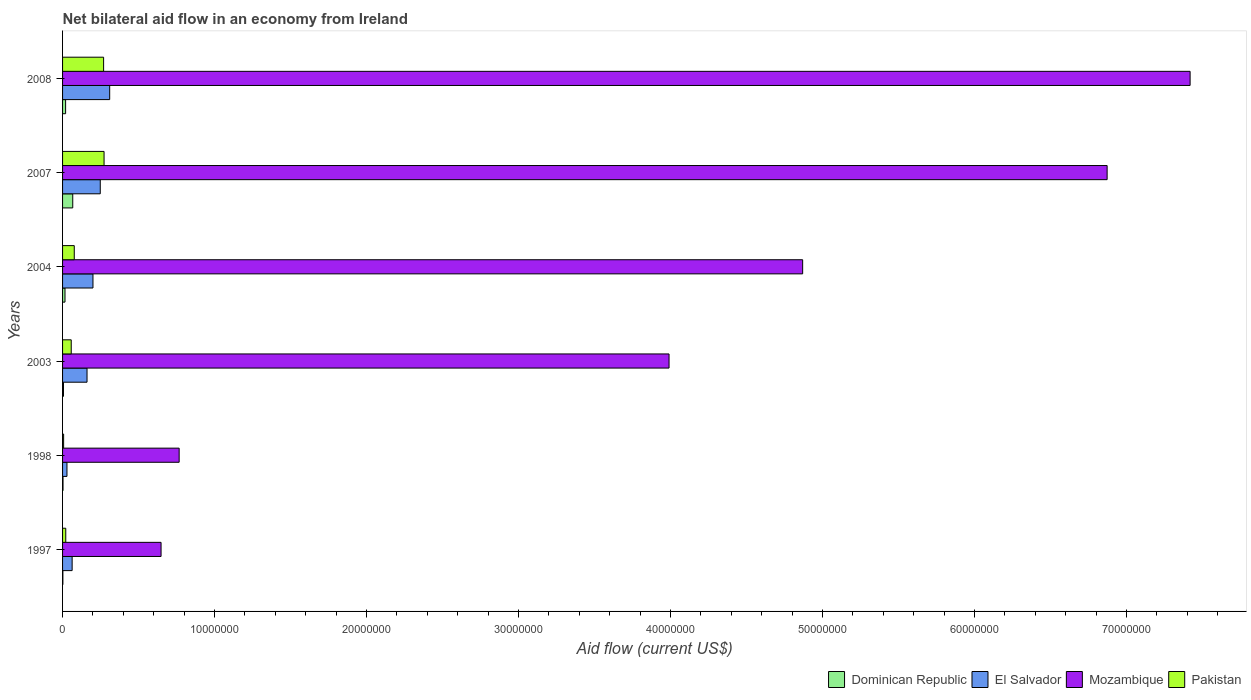How many different coloured bars are there?
Offer a terse response. 4. How many groups of bars are there?
Your answer should be very brief. 6. How many bars are there on the 3rd tick from the top?
Your answer should be very brief. 4. How many bars are there on the 2nd tick from the bottom?
Ensure brevity in your answer.  4. In how many cases, is the number of bars for a given year not equal to the number of legend labels?
Keep it short and to the point. 0. What is the net bilateral aid flow in El Salvador in 1997?
Give a very brief answer. 6.30e+05. Across all years, what is the maximum net bilateral aid flow in Dominican Republic?
Provide a succinct answer. 6.70e+05. Across all years, what is the minimum net bilateral aid flow in Pakistan?
Your response must be concise. 7.00e+04. What is the total net bilateral aid flow in Pakistan in the graph?
Keep it short and to the point. 7.05e+06. What is the difference between the net bilateral aid flow in Dominican Republic in 2007 and that in 2008?
Your response must be concise. 4.70e+05. What is the difference between the net bilateral aid flow in Dominican Republic in 2004 and the net bilateral aid flow in Mozambique in 1997?
Provide a short and direct response. -6.32e+06. What is the average net bilateral aid flow in Dominican Republic per year?
Give a very brief answer. 1.90e+05. In the year 1997, what is the difference between the net bilateral aid flow in Dominican Republic and net bilateral aid flow in Mozambique?
Your answer should be very brief. -6.46e+06. What is the ratio of the net bilateral aid flow in Dominican Republic in 1998 to that in 2007?
Make the answer very short. 0.04. Is the net bilateral aid flow in Pakistan in 1997 less than that in 2008?
Your answer should be very brief. Yes. What is the difference between the highest and the second highest net bilateral aid flow in Dominican Republic?
Give a very brief answer. 4.70e+05. What is the difference between the highest and the lowest net bilateral aid flow in Dominican Republic?
Provide a short and direct response. 6.50e+05. Is the sum of the net bilateral aid flow in Dominican Republic in 1997 and 2004 greater than the maximum net bilateral aid flow in Mozambique across all years?
Offer a terse response. No. What does the 3rd bar from the top in 2003 represents?
Give a very brief answer. El Salvador. What does the 3rd bar from the bottom in 2003 represents?
Provide a succinct answer. Mozambique. How many years are there in the graph?
Provide a short and direct response. 6. What is the difference between two consecutive major ticks on the X-axis?
Provide a succinct answer. 1.00e+07. Are the values on the major ticks of X-axis written in scientific E-notation?
Ensure brevity in your answer.  No. Does the graph contain any zero values?
Provide a succinct answer. No. Does the graph contain grids?
Provide a succinct answer. No. Where does the legend appear in the graph?
Offer a terse response. Bottom right. What is the title of the graph?
Keep it short and to the point. Net bilateral aid flow in an economy from Ireland. Does "Serbia" appear as one of the legend labels in the graph?
Ensure brevity in your answer.  No. What is the label or title of the Y-axis?
Your response must be concise. Years. What is the Aid flow (current US$) in El Salvador in 1997?
Your answer should be compact. 6.30e+05. What is the Aid flow (current US$) in Mozambique in 1997?
Provide a short and direct response. 6.48e+06. What is the Aid flow (current US$) in Pakistan in 1997?
Provide a short and direct response. 2.10e+05. What is the Aid flow (current US$) in Dominican Republic in 1998?
Make the answer very short. 3.00e+04. What is the Aid flow (current US$) in Mozambique in 1998?
Your answer should be very brief. 7.67e+06. What is the Aid flow (current US$) of Dominican Republic in 2003?
Ensure brevity in your answer.  6.00e+04. What is the Aid flow (current US$) in El Salvador in 2003?
Offer a very short reply. 1.61e+06. What is the Aid flow (current US$) in Mozambique in 2003?
Provide a succinct answer. 3.99e+07. What is the Aid flow (current US$) in Pakistan in 2003?
Ensure brevity in your answer.  5.70e+05. What is the Aid flow (current US$) of Dominican Republic in 2004?
Provide a succinct answer. 1.60e+05. What is the Aid flow (current US$) of Mozambique in 2004?
Your response must be concise. 4.87e+07. What is the Aid flow (current US$) in Pakistan in 2004?
Keep it short and to the point. 7.70e+05. What is the Aid flow (current US$) in Dominican Republic in 2007?
Ensure brevity in your answer.  6.70e+05. What is the Aid flow (current US$) of El Salvador in 2007?
Keep it short and to the point. 2.48e+06. What is the Aid flow (current US$) in Mozambique in 2007?
Keep it short and to the point. 6.87e+07. What is the Aid flow (current US$) in Pakistan in 2007?
Make the answer very short. 2.73e+06. What is the Aid flow (current US$) of El Salvador in 2008?
Your answer should be compact. 3.10e+06. What is the Aid flow (current US$) of Mozambique in 2008?
Ensure brevity in your answer.  7.42e+07. What is the Aid flow (current US$) in Pakistan in 2008?
Provide a short and direct response. 2.70e+06. Across all years, what is the maximum Aid flow (current US$) in Dominican Republic?
Make the answer very short. 6.70e+05. Across all years, what is the maximum Aid flow (current US$) in El Salvador?
Ensure brevity in your answer.  3.10e+06. Across all years, what is the maximum Aid flow (current US$) of Mozambique?
Provide a succinct answer. 7.42e+07. Across all years, what is the maximum Aid flow (current US$) of Pakistan?
Ensure brevity in your answer.  2.73e+06. Across all years, what is the minimum Aid flow (current US$) in Dominican Republic?
Keep it short and to the point. 2.00e+04. Across all years, what is the minimum Aid flow (current US$) of El Salvador?
Provide a succinct answer. 2.90e+05. Across all years, what is the minimum Aid flow (current US$) in Mozambique?
Your response must be concise. 6.48e+06. What is the total Aid flow (current US$) in Dominican Republic in the graph?
Provide a succinct answer. 1.14e+06. What is the total Aid flow (current US$) in El Salvador in the graph?
Keep it short and to the point. 1.01e+07. What is the total Aid flow (current US$) in Mozambique in the graph?
Your response must be concise. 2.46e+08. What is the total Aid flow (current US$) of Pakistan in the graph?
Offer a terse response. 7.05e+06. What is the difference between the Aid flow (current US$) of Dominican Republic in 1997 and that in 1998?
Your answer should be very brief. -10000. What is the difference between the Aid flow (current US$) in Mozambique in 1997 and that in 1998?
Make the answer very short. -1.19e+06. What is the difference between the Aid flow (current US$) of Pakistan in 1997 and that in 1998?
Your response must be concise. 1.40e+05. What is the difference between the Aid flow (current US$) in El Salvador in 1997 and that in 2003?
Your response must be concise. -9.80e+05. What is the difference between the Aid flow (current US$) of Mozambique in 1997 and that in 2003?
Ensure brevity in your answer.  -3.34e+07. What is the difference between the Aid flow (current US$) of Pakistan in 1997 and that in 2003?
Provide a succinct answer. -3.60e+05. What is the difference between the Aid flow (current US$) of El Salvador in 1997 and that in 2004?
Offer a very short reply. -1.37e+06. What is the difference between the Aid flow (current US$) of Mozambique in 1997 and that in 2004?
Your response must be concise. -4.22e+07. What is the difference between the Aid flow (current US$) in Pakistan in 1997 and that in 2004?
Give a very brief answer. -5.60e+05. What is the difference between the Aid flow (current US$) in Dominican Republic in 1997 and that in 2007?
Your response must be concise. -6.50e+05. What is the difference between the Aid flow (current US$) in El Salvador in 1997 and that in 2007?
Offer a terse response. -1.85e+06. What is the difference between the Aid flow (current US$) of Mozambique in 1997 and that in 2007?
Provide a short and direct response. -6.22e+07. What is the difference between the Aid flow (current US$) of Pakistan in 1997 and that in 2007?
Provide a succinct answer. -2.52e+06. What is the difference between the Aid flow (current US$) of Dominican Republic in 1997 and that in 2008?
Ensure brevity in your answer.  -1.80e+05. What is the difference between the Aid flow (current US$) in El Salvador in 1997 and that in 2008?
Provide a succinct answer. -2.47e+06. What is the difference between the Aid flow (current US$) in Mozambique in 1997 and that in 2008?
Offer a terse response. -6.77e+07. What is the difference between the Aid flow (current US$) of Pakistan in 1997 and that in 2008?
Provide a succinct answer. -2.49e+06. What is the difference between the Aid flow (current US$) in El Salvador in 1998 and that in 2003?
Offer a terse response. -1.32e+06. What is the difference between the Aid flow (current US$) in Mozambique in 1998 and that in 2003?
Provide a short and direct response. -3.22e+07. What is the difference between the Aid flow (current US$) of Pakistan in 1998 and that in 2003?
Ensure brevity in your answer.  -5.00e+05. What is the difference between the Aid flow (current US$) in El Salvador in 1998 and that in 2004?
Make the answer very short. -1.71e+06. What is the difference between the Aid flow (current US$) of Mozambique in 1998 and that in 2004?
Offer a very short reply. -4.10e+07. What is the difference between the Aid flow (current US$) in Pakistan in 1998 and that in 2004?
Your response must be concise. -7.00e+05. What is the difference between the Aid flow (current US$) in Dominican Republic in 1998 and that in 2007?
Your answer should be very brief. -6.40e+05. What is the difference between the Aid flow (current US$) of El Salvador in 1998 and that in 2007?
Offer a terse response. -2.19e+06. What is the difference between the Aid flow (current US$) of Mozambique in 1998 and that in 2007?
Your answer should be very brief. -6.10e+07. What is the difference between the Aid flow (current US$) in Pakistan in 1998 and that in 2007?
Ensure brevity in your answer.  -2.66e+06. What is the difference between the Aid flow (current US$) in El Salvador in 1998 and that in 2008?
Your answer should be compact. -2.81e+06. What is the difference between the Aid flow (current US$) in Mozambique in 1998 and that in 2008?
Make the answer very short. -6.65e+07. What is the difference between the Aid flow (current US$) in Pakistan in 1998 and that in 2008?
Give a very brief answer. -2.63e+06. What is the difference between the Aid flow (current US$) in El Salvador in 2003 and that in 2004?
Your answer should be very brief. -3.90e+05. What is the difference between the Aid flow (current US$) of Mozambique in 2003 and that in 2004?
Your answer should be very brief. -8.79e+06. What is the difference between the Aid flow (current US$) of Dominican Republic in 2003 and that in 2007?
Offer a terse response. -6.10e+05. What is the difference between the Aid flow (current US$) of El Salvador in 2003 and that in 2007?
Your response must be concise. -8.70e+05. What is the difference between the Aid flow (current US$) in Mozambique in 2003 and that in 2007?
Keep it short and to the point. -2.88e+07. What is the difference between the Aid flow (current US$) of Pakistan in 2003 and that in 2007?
Offer a very short reply. -2.16e+06. What is the difference between the Aid flow (current US$) in Dominican Republic in 2003 and that in 2008?
Your answer should be compact. -1.40e+05. What is the difference between the Aid flow (current US$) of El Salvador in 2003 and that in 2008?
Your answer should be very brief. -1.49e+06. What is the difference between the Aid flow (current US$) of Mozambique in 2003 and that in 2008?
Provide a short and direct response. -3.43e+07. What is the difference between the Aid flow (current US$) in Pakistan in 2003 and that in 2008?
Offer a very short reply. -2.13e+06. What is the difference between the Aid flow (current US$) in Dominican Republic in 2004 and that in 2007?
Offer a very short reply. -5.10e+05. What is the difference between the Aid flow (current US$) of El Salvador in 2004 and that in 2007?
Give a very brief answer. -4.80e+05. What is the difference between the Aid flow (current US$) in Mozambique in 2004 and that in 2007?
Make the answer very short. -2.00e+07. What is the difference between the Aid flow (current US$) of Pakistan in 2004 and that in 2007?
Your response must be concise. -1.96e+06. What is the difference between the Aid flow (current US$) in Dominican Republic in 2004 and that in 2008?
Give a very brief answer. -4.00e+04. What is the difference between the Aid flow (current US$) of El Salvador in 2004 and that in 2008?
Offer a very short reply. -1.10e+06. What is the difference between the Aid flow (current US$) of Mozambique in 2004 and that in 2008?
Offer a very short reply. -2.55e+07. What is the difference between the Aid flow (current US$) in Pakistan in 2004 and that in 2008?
Provide a succinct answer. -1.93e+06. What is the difference between the Aid flow (current US$) in Dominican Republic in 2007 and that in 2008?
Keep it short and to the point. 4.70e+05. What is the difference between the Aid flow (current US$) in El Salvador in 2007 and that in 2008?
Provide a short and direct response. -6.20e+05. What is the difference between the Aid flow (current US$) of Mozambique in 2007 and that in 2008?
Offer a terse response. -5.46e+06. What is the difference between the Aid flow (current US$) in Dominican Republic in 1997 and the Aid flow (current US$) in El Salvador in 1998?
Your answer should be compact. -2.70e+05. What is the difference between the Aid flow (current US$) of Dominican Republic in 1997 and the Aid flow (current US$) of Mozambique in 1998?
Your response must be concise. -7.65e+06. What is the difference between the Aid flow (current US$) in El Salvador in 1997 and the Aid flow (current US$) in Mozambique in 1998?
Your answer should be compact. -7.04e+06. What is the difference between the Aid flow (current US$) in El Salvador in 1997 and the Aid flow (current US$) in Pakistan in 1998?
Your answer should be compact. 5.60e+05. What is the difference between the Aid flow (current US$) in Mozambique in 1997 and the Aid flow (current US$) in Pakistan in 1998?
Offer a terse response. 6.41e+06. What is the difference between the Aid flow (current US$) of Dominican Republic in 1997 and the Aid flow (current US$) of El Salvador in 2003?
Keep it short and to the point. -1.59e+06. What is the difference between the Aid flow (current US$) in Dominican Republic in 1997 and the Aid flow (current US$) in Mozambique in 2003?
Give a very brief answer. -3.99e+07. What is the difference between the Aid flow (current US$) in Dominican Republic in 1997 and the Aid flow (current US$) in Pakistan in 2003?
Provide a short and direct response. -5.50e+05. What is the difference between the Aid flow (current US$) in El Salvador in 1997 and the Aid flow (current US$) in Mozambique in 2003?
Provide a short and direct response. -3.93e+07. What is the difference between the Aid flow (current US$) in Mozambique in 1997 and the Aid flow (current US$) in Pakistan in 2003?
Ensure brevity in your answer.  5.91e+06. What is the difference between the Aid flow (current US$) in Dominican Republic in 1997 and the Aid flow (current US$) in El Salvador in 2004?
Keep it short and to the point. -1.98e+06. What is the difference between the Aid flow (current US$) in Dominican Republic in 1997 and the Aid flow (current US$) in Mozambique in 2004?
Your answer should be very brief. -4.87e+07. What is the difference between the Aid flow (current US$) of Dominican Republic in 1997 and the Aid flow (current US$) of Pakistan in 2004?
Ensure brevity in your answer.  -7.50e+05. What is the difference between the Aid flow (current US$) of El Salvador in 1997 and the Aid flow (current US$) of Mozambique in 2004?
Your answer should be compact. -4.81e+07. What is the difference between the Aid flow (current US$) of Mozambique in 1997 and the Aid flow (current US$) of Pakistan in 2004?
Provide a succinct answer. 5.71e+06. What is the difference between the Aid flow (current US$) in Dominican Republic in 1997 and the Aid flow (current US$) in El Salvador in 2007?
Offer a very short reply. -2.46e+06. What is the difference between the Aid flow (current US$) in Dominican Republic in 1997 and the Aid flow (current US$) in Mozambique in 2007?
Offer a very short reply. -6.87e+07. What is the difference between the Aid flow (current US$) in Dominican Republic in 1997 and the Aid flow (current US$) in Pakistan in 2007?
Offer a very short reply. -2.71e+06. What is the difference between the Aid flow (current US$) in El Salvador in 1997 and the Aid flow (current US$) in Mozambique in 2007?
Provide a succinct answer. -6.81e+07. What is the difference between the Aid flow (current US$) of El Salvador in 1997 and the Aid flow (current US$) of Pakistan in 2007?
Your answer should be very brief. -2.10e+06. What is the difference between the Aid flow (current US$) in Mozambique in 1997 and the Aid flow (current US$) in Pakistan in 2007?
Offer a very short reply. 3.75e+06. What is the difference between the Aid flow (current US$) of Dominican Republic in 1997 and the Aid flow (current US$) of El Salvador in 2008?
Your answer should be very brief. -3.08e+06. What is the difference between the Aid flow (current US$) in Dominican Republic in 1997 and the Aid flow (current US$) in Mozambique in 2008?
Offer a very short reply. -7.42e+07. What is the difference between the Aid flow (current US$) of Dominican Republic in 1997 and the Aid flow (current US$) of Pakistan in 2008?
Your answer should be compact. -2.68e+06. What is the difference between the Aid flow (current US$) in El Salvador in 1997 and the Aid flow (current US$) in Mozambique in 2008?
Ensure brevity in your answer.  -7.36e+07. What is the difference between the Aid flow (current US$) in El Salvador in 1997 and the Aid flow (current US$) in Pakistan in 2008?
Give a very brief answer. -2.07e+06. What is the difference between the Aid flow (current US$) of Mozambique in 1997 and the Aid flow (current US$) of Pakistan in 2008?
Your response must be concise. 3.78e+06. What is the difference between the Aid flow (current US$) of Dominican Republic in 1998 and the Aid flow (current US$) of El Salvador in 2003?
Your response must be concise. -1.58e+06. What is the difference between the Aid flow (current US$) in Dominican Republic in 1998 and the Aid flow (current US$) in Mozambique in 2003?
Ensure brevity in your answer.  -3.99e+07. What is the difference between the Aid flow (current US$) in Dominican Republic in 1998 and the Aid flow (current US$) in Pakistan in 2003?
Ensure brevity in your answer.  -5.40e+05. What is the difference between the Aid flow (current US$) of El Salvador in 1998 and the Aid flow (current US$) of Mozambique in 2003?
Provide a succinct answer. -3.96e+07. What is the difference between the Aid flow (current US$) of El Salvador in 1998 and the Aid flow (current US$) of Pakistan in 2003?
Make the answer very short. -2.80e+05. What is the difference between the Aid flow (current US$) of Mozambique in 1998 and the Aid flow (current US$) of Pakistan in 2003?
Provide a short and direct response. 7.10e+06. What is the difference between the Aid flow (current US$) of Dominican Republic in 1998 and the Aid flow (current US$) of El Salvador in 2004?
Keep it short and to the point. -1.97e+06. What is the difference between the Aid flow (current US$) of Dominican Republic in 1998 and the Aid flow (current US$) of Mozambique in 2004?
Offer a terse response. -4.87e+07. What is the difference between the Aid flow (current US$) in Dominican Republic in 1998 and the Aid flow (current US$) in Pakistan in 2004?
Make the answer very short. -7.40e+05. What is the difference between the Aid flow (current US$) in El Salvador in 1998 and the Aid flow (current US$) in Mozambique in 2004?
Your answer should be very brief. -4.84e+07. What is the difference between the Aid flow (current US$) of El Salvador in 1998 and the Aid flow (current US$) of Pakistan in 2004?
Provide a short and direct response. -4.80e+05. What is the difference between the Aid flow (current US$) in Mozambique in 1998 and the Aid flow (current US$) in Pakistan in 2004?
Provide a succinct answer. 6.90e+06. What is the difference between the Aid flow (current US$) in Dominican Republic in 1998 and the Aid flow (current US$) in El Salvador in 2007?
Provide a short and direct response. -2.45e+06. What is the difference between the Aid flow (current US$) in Dominican Republic in 1998 and the Aid flow (current US$) in Mozambique in 2007?
Ensure brevity in your answer.  -6.87e+07. What is the difference between the Aid flow (current US$) in Dominican Republic in 1998 and the Aid flow (current US$) in Pakistan in 2007?
Offer a terse response. -2.70e+06. What is the difference between the Aid flow (current US$) in El Salvador in 1998 and the Aid flow (current US$) in Mozambique in 2007?
Make the answer very short. -6.84e+07. What is the difference between the Aid flow (current US$) in El Salvador in 1998 and the Aid flow (current US$) in Pakistan in 2007?
Ensure brevity in your answer.  -2.44e+06. What is the difference between the Aid flow (current US$) of Mozambique in 1998 and the Aid flow (current US$) of Pakistan in 2007?
Your response must be concise. 4.94e+06. What is the difference between the Aid flow (current US$) of Dominican Republic in 1998 and the Aid flow (current US$) of El Salvador in 2008?
Offer a very short reply. -3.07e+06. What is the difference between the Aid flow (current US$) in Dominican Republic in 1998 and the Aid flow (current US$) in Mozambique in 2008?
Make the answer very short. -7.42e+07. What is the difference between the Aid flow (current US$) in Dominican Republic in 1998 and the Aid flow (current US$) in Pakistan in 2008?
Make the answer very short. -2.67e+06. What is the difference between the Aid flow (current US$) of El Salvador in 1998 and the Aid flow (current US$) of Mozambique in 2008?
Give a very brief answer. -7.39e+07. What is the difference between the Aid flow (current US$) in El Salvador in 1998 and the Aid flow (current US$) in Pakistan in 2008?
Your answer should be very brief. -2.41e+06. What is the difference between the Aid flow (current US$) of Mozambique in 1998 and the Aid flow (current US$) of Pakistan in 2008?
Give a very brief answer. 4.97e+06. What is the difference between the Aid flow (current US$) in Dominican Republic in 2003 and the Aid flow (current US$) in El Salvador in 2004?
Your response must be concise. -1.94e+06. What is the difference between the Aid flow (current US$) in Dominican Republic in 2003 and the Aid flow (current US$) in Mozambique in 2004?
Give a very brief answer. -4.86e+07. What is the difference between the Aid flow (current US$) in Dominican Republic in 2003 and the Aid flow (current US$) in Pakistan in 2004?
Provide a succinct answer. -7.10e+05. What is the difference between the Aid flow (current US$) in El Salvador in 2003 and the Aid flow (current US$) in Mozambique in 2004?
Give a very brief answer. -4.71e+07. What is the difference between the Aid flow (current US$) of El Salvador in 2003 and the Aid flow (current US$) of Pakistan in 2004?
Give a very brief answer. 8.40e+05. What is the difference between the Aid flow (current US$) of Mozambique in 2003 and the Aid flow (current US$) of Pakistan in 2004?
Your response must be concise. 3.91e+07. What is the difference between the Aid flow (current US$) of Dominican Republic in 2003 and the Aid flow (current US$) of El Salvador in 2007?
Ensure brevity in your answer.  -2.42e+06. What is the difference between the Aid flow (current US$) of Dominican Republic in 2003 and the Aid flow (current US$) of Mozambique in 2007?
Keep it short and to the point. -6.87e+07. What is the difference between the Aid flow (current US$) in Dominican Republic in 2003 and the Aid flow (current US$) in Pakistan in 2007?
Offer a terse response. -2.67e+06. What is the difference between the Aid flow (current US$) of El Salvador in 2003 and the Aid flow (current US$) of Mozambique in 2007?
Keep it short and to the point. -6.71e+07. What is the difference between the Aid flow (current US$) in El Salvador in 2003 and the Aid flow (current US$) in Pakistan in 2007?
Provide a short and direct response. -1.12e+06. What is the difference between the Aid flow (current US$) of Mozambique in 2003 and the Aid flow (current US$) of Pakistan in 2007?
Give a very brief answer. 3.72e+07. What is the difference between the Aid flow (current US$) of Dominican Republic in 2003 and the Aid flow (current US$) of El Salvador in 2008?
Offer a very short reply. -3.04e+06. What is the difference between the Aid flow (current US$) of Dominican Republic in 2003 and the Aid flow (current US$) of Mozambique in 2008?
Provide a short and direct response. -7.41e+07. What is the difference between the Aid flow (current US$) of Dominican Republic in 2003 and the Aid flow (current US$) of Pakistan in 2008?
Keep it short and to the point. -2.64e+06. What is the difference between the Aid flow (current US$) in El Salvador in 2003 and the Aid flow (current US$) in Mozambique in 2008?
Provide a succinct answer. -7.26e+07. What is the difference between the Aid flow (current US$) of El Salvador in 2003 and the Aid flow (current US$) of Pakistan in 2008?
Give a very brief answer. -1.09e+06. What is the difference between the Aid flow (current US$) of Mozambique in 2003 and the Aid flow (current US$) of Pakistan in 2008?
Make the answer very short. 3.72e+07. What is the difference between the Aid flow (current US$) in Dominican Republic in 2004 and the Aid flow (current US$) in El Salvador in 2007?
Offer a terse response. -2.32e+06. What is the difference between the Aid flow (current US$) in Dominican Republic in 2004 and the Aid flow (current US$) in Mozambique in 2007?
Your answer should be compact. -6.86e+07. What is the difference between the Aid flow (current US$) in Dominican Republic in 2004 and the Aid flow (current US$) in Pakistan in 2007?
Offer a terse response. -2.57e+06. What is the difference between the Aid flow (current US$) in El Salvador in 2004 and the Aid flow (current US$) in Mozambique in 2007?
Your answer should be very brief. -6.67e+07. What is the difference between the Aid flow (current US$) in El Salvador in 2004 and the Aid flow (current US$) in Pakistan in 2007?
Offer a very short reply. -7.30e+05. What is the difference between the Aid flow (current US$) of Mozambique in 2004 and the Aid flow (current US$) of Pakistan in 2007?
Your answer should be very brief. 4.60e+07. What is the difference between the Aid flow (current US$) in Dominican Republic in 2004 and the Aid flow (current US$) in El Salvador in 2008?
Keep it short and to the point. -2.94e+06. What is the difference between the Aid flow (current US$) in Dominican Republic in 2004 and the Aid flow (current US$) in Mozambique in 2008?
Provide a short and direct response. -7.40e+07. What is the difference between the Aid flow (current US$) in Dominican Republic in 2004 and the Aid flow (current US$) in Pakistan in 2008?
Provide a short and direct response. -2.54e+06. What is the difference between the Aid flow (current US$) in El Salvador in 2004 and the Aid flow (current US$) in Mozambique in 2008?
Offer a terse response. -7.22e+07. What is the difference between the Aid flow (current US$) of El Salvador in 2004 and the Aid flow (current US$) of Pakistan in 2008?
Provide a short and direct response. -7.00e+05. What is the difference between the Aid flow (current US$) in Mozambique in 2004 and the Aid flow (current US$) in Pakistan in 2008?
Your answer should be very brief. 4.60e+07. What is the difference between the Aid flow (current US$) in Dominican Republic in 2007 and the Aid flow (current US$) in El Salvador in 2008?
Your answer should be compact. -2.43e+06. What is the difference between the Aid flow (current US$) of Dominican Republic in 2007 and the Aid flow (current US$) of Mozambique in 2008?
Provide a succinct answer. -7.35e+07. What is the difference between the Aid flow (current US$) in Dominican Republic in 2007 and the Aid flow (current US$) in Pakistan in 2008?
Provide a succinct answer. -2.03e+06. What is the difference between the Aid flow (current US$) in El Salvador in 2007 and the Aid flow (current US$) in Mozambique in 2008?
Provide a succinct answer. -7.17e+07. What is the difference between the Aid flow (current US$) in Mozambique in 2007 and the Aid flow (current US$) in Pakistan in 2008?
Make the answer very short. 6.60e+07. What is the average Aid flow (current US$) of Dominican Republic per year?
Your answer should be very brief. 1.90e+05. What is the average Aid flow (current US$) of El Salvador per year?
Make the answer very short. 1.68e+06. What is the average Aid flow (current US$) of Mozambique per year?
Your answer should be very brief. 4.09e+07. What is the average Aid flow (current US$) of Pakistan per year?
Provide a succinct answer. 1.18e+06. In the year 1997, what is the difference between the Aid flow (current US$) in Dominican Republic and Aid flow (current US$) in El Salvador?
Ensure brevity in your answer.  -6.10e+05. In the year 1997, what is the difference between the Aid flow (current US$) of Dominican Republic and Aid flow (current US$) of Mozambique?
Offer a very short reply. -6.46e+06. In the year 1997, what is the difference between the Aid flow (current US$) of El Salvador and Aid flow (current US$) of Mozambique?
Offer a terse response. -5.85e+06. In the year 1997, what is the difference between the Aid flow (current US$) of Mozambique and Aid flow (current US$) of Pakistan?
Your answer should be very brief. 6.27e+06. In the year 1998, what is the difference between the Aid flow (current US$) of Dominican Republic and Aid flow (current US$) of Mozambique?
Keep it short and to the point. -7.64e+06. In the year 1998, what is the difference between the Aid flow (current US$) of El Salvador and Aid flow (current US$) of Mozambique?
Your answer should be compact. -7.38e+06. In the year 1998, what is the difference between the Aid flow (current US$) in El Salvador and Aid flow (current US$) in Pakistan?
Keep it short and to the point. 2.20e+05. In the year 1998, what is the difference between the Aid flow (current US$) of Mozambique and Aid flow (current US$) of Pakistan?
Offer a terse response. 7.60e+06. In the year 2003, what is the difference between the Aid flow (current US$) of Dominican Republic and Aid flow (current US$) of El Salvador?
Keep it short and to the point. -1.55e+06. In the year 2003, what is the difference between the Aid flow (current US$) of Dominican Republic and Aid flow (current US$) of Mozambique?
Give a very brief answer. -3.98e+07. In the year 2003, what is the difference between the Aid flow (current US$) of Dominican Republic and Aid flow (current US$) of Pakistan?
Make the answer very short. -5.10e+05. In the year 2003, what is the difference between the Aid flow (current US$) of El Salvador and Aid flow (current US$) of Mozambique?
Offer a very short reply. -3.83e+07. In the year 2003, what is the difference between the Aid flow (current US$) of El Salvador and Aid flow (current US$) of Pakistan?
Make the answer very short. 1.04e+06. In the year 2003, what is the difference between the Aid flow (current US$) of Mozambique and Aid flow (current US$) of Pakistan?
Your answer should be very brief. 3.93e+07. In the year 2004, what is the difference between the Aid flow (current US$) of Dominican Republic and Aid flow (current US$) of El Salvador?
Offer a very short reply. -1.84e+06. In the year 2004, what is the difference between the Aid flow (current US$) in Dominican Republic and Aid flow (current US$) in Mozambique?
Provide a short and direct response. -4.85e+07. In the year 2004, what is the difference between the Aid flow (current US$) in Dominican Republic and Aid flow (current US$) in Pakistan?
Your answer should be very brief. -6.10e+05. In the year 2004, what is the difference between the Aid flow (current US$) in El Salvador and Aid flow (current US$) in Mozambique?
Your answer should be very brief. -4.67e+07. In the year 2004, what is the difference between the Aid flow (current US$) in El Salvador and Aid flow (current US$) in Pakistan?
Ensure brevity in your answer.  1.23e+06. In the year 2004, what is the difference between the Aid flow (current US$) of Mozambique and Aid flow (current US$) of Pakistan?
Ensure brevity in your answer.  4.79e+07. In the year 2007, what is the difference between the Aid flow (current US$) in Dominican Republic and Aid flow (current US$) in El Salvador?
Your answer should be compact. -1.81e+06. In the year 2007, what is the difference between the Aid flow (current US$) in Dominican Republic and Aid flow (current US$) in Mozambique?
Provide a short and direct response. -6.80e+07. In the year 2007, what is the difference between the Aid flow (current US$) in Dominican Republic and Aid flow (current US$) in Pakistan?
Give a very brief answer. -2.06e+06. In the year 2007, what is the difference between the Aid flow (current US$) in El Salvador and Aid flow (current US$) in Mozambique?
Your answer should be compact. -6.62e+07. In the year 2007, what is the difference between the Aid flow (current US$) in El Salvador and Aid flow (current US$) in Pakistan?
Your answer should be compact. -2.50e+05. In the year 2007, what is the difference between the Aid flow (current US$) in Mozambique and Aid flow (current US$) in Pakistan?
Your answer should be compact. 6.60e+07. In the year 2008, what is the difference between the Aid flow (current US$) of Dominican Republic and Aid flow (current US$) of El Salvador?
Provide a succinct answer. -2.90e+06. In the year 2008, what is the difference between the Aid flow (current US$) in Dominican Republic and Aid flow (current US$) in Mozambique?
Offer a terse response. -7.40e+07. In the year 2008, what is the difference between the Aid flow (current US$) in Dominican Republic and Aid flow (current US$) in Pakistan?
Provide a short and direct response. -2.50e+06. In the year 2008, what is the difference between the Aid flow (current US$) of El Salvador and Aid flow (current US$) of Mozambique?
Give a very brief answer. -7.11e+07. In the year 2008, what is the difference between the Aid flow (current US$) in El Salvador and Aid flow (current US$) in Pakistan?
Keep it short and to the point. 4.00e+05. In the year 2008, what is the difference between the Aid flow (current US$) of Mozambique and Aid flow (current US$) of Pakistan?
Ensure brevity in your answer.  7.15e+07. What is the ratio of the Aid flow (current US$) in Dominican Republic in 1997 to that in 1998?
Make the answer very short. 0.67. What is the ratio of the Aid flow (current US$) in El Salvador in 1997 to that in 1998?
Give a very brief answer. 2.17. What is the ratio of the Aid flow (current US$) in Mozambique in 1997 to that in 1998?
Offer a terse response. 0.84. What is the ratio of the Aid flow (current US$) of El Salvador in 1997 to that in 2003?
Make the answer very short. 0.39. What is the ratio of the Aid flow (current US$) in Mozambique in 1997 to that in 2003?
Your response must be concise. 0.16. What is the ratio of the Aid flow (current US$) of Pakistan in 1997 to that in 2003?
Provide a short and direct response. 0.37. What is the ratio of the Aid flow (current US$) of Dominican Republic in 1997 to that in 2004?
Offer a terse response. 0.12. What is the ratio of the Aid flow (current US$) of El Salvador in 1997 to that in 2004?
Give a very brief answer. 0.32. What is the ratio of the Aid flow (current US$) in Mozambique in 1997 to that in 2004?
Your answer should be compact. 0.13. What is the ratio of the Aid flow (current US$) in Pakistan in 1997 to that in 2004?
Provide a succinct answer. 0.27. What is the ratio of the Aid flow (current US$) of Dominican Republic in 1997 to that in 2007?
Your answer should be compact. 0.03. What is the ratio of the Aid flow (current US$) in El Salvador in 1997 to that in 2007?
Offer a terse response. 0.25. What is the ratio of the Aid flow (current US$) in Mozambique in 1997 to that in 2007?
Your answer should be very brief. 0.09. What is the ratio of the Aid flow (current US$) in Pakistan in 1997 to that in 2007?
Provide a short and direct response. 0.08. What is the ratio of the Aid flow (current US$) of Dominican Republic in 1997 to that in 2008?
Your answer should be very brief. 0.1. What is the ratio of the Aid flow (current US$) in El Salvador in 1997 to that in 2008?
Offer a terse response. 0.2. What is the ratio of the Aid flow (current US$) of Mozambique in 1997 to that in 2008?
Make the answer very short. 0.09. What is the ratio of the Aid flow (current US$) of Pakistan in 1997 to that in 2008?
Your response must be concise. 0.08. What is the ratio of the Aid flow (current US$) in El Salvador in 1998 to that in 2003?
Your answer should be compact. 0.18. What is the ratio of the Aid flow (current US$) in Mozambique in 1998 to that in 2003?
Offer a very short reply. 0.19. What is the ratio of the Aid flow (current US$) of Pakistan in 1998 to that in 2003?
Your answer should be compact. 0.12. What is the ratio of the Aid flow (current US$) of Dominican Republic in 1998 to that in 2004?
Your answer should be very brief. 0.19. What is the ratio of the Aid flow (current US$) in El Salvador in 1998 to that in 2004?
Make the answer very short. 0.14. What is the ratio of the Aid flow (current US$) of Mozambique in 1998 to that in 2004?
Ensure brevity in your answer.  0.16. What is the ratio of the Aid flow (current US$) in Pakistan in 1998 to that in 2004?
Keep it short and to the point. 0.09. What is the ratio of the Aid flow (current US$) of Dominican Republic in 1998 to that in 2007?
Offer a very short reply. 0.04. What is the ratio of the Aid flow (current US$) of El Salvador in 1998 to that in 2007?
Make the answer very short. 0.12. What is the ratio of the Aid flow (current US$) of Mozambique in 1998 to that in 2007?
Your answer should be very brief. 0.11. What is the ratio of the Aid flow (current US$) of Pakistan in 1998 to that in 2007?
Your answer should be compact. 0.03. What is the ratio of the Aid flow (current US$) in El Salvador in 1998 to that in 2008?
Provide a succinct answer. 0.09. What is the ratio of the Aid flow (current US$) of Mozambique in 1998 to that in 2008?
Your response must be concise. 0.1. What is the ratio of the Aid flow (current US$) of Pakistan in 1998 to that in 2008?
Provide a succinct answer. 0.03. What is the ratio of the Aid flow (current US$) of El Salvador in 2003 to that in 2004?
Provide a succinct answer. 0.81. What is the ratio of the Aid flow (current US$) of Mozambique in 2003 to that in 2004?
Give a very brief answer. 0.82. What is the ratio of the Aid flow (current US$) of Pakistan in 2003 to that in 2004?
Offer a terse response. 0.74. What is the ratio of the Aid flow (current US$) in Dominican Republic in 2003 to that in 2007?
Your response must be concise. 0.09. What is the ratio of the Aid flow (current US$) of El Salvador in 2003 to that in 2007?
Ensure brevity in your answer.  0.65. What is the ratio of the Aid flow (current US$) of Mozambique in 2003 to that in 2007?
Your answer should be compact. 0.58. What is the ratio of the Aid flow (current US$) of Pakistan in 2003 to that in 2007?
Provide a succinct answer. 0.21. What is the ratio of the Aid flow (current US$) of El Salvador in 2003 to that in 2008?
Provide a succinct answer. 0.52. What is the ratio of the Aid flow (current US$) in Mozambique in 2003 to that in 2008?
Offer a terse response. 0.54. What is the ratio of the Aid flow (current US$) of Pakistan in 2003 to that in 2008?
Provide a succinct answer. 0.21. What is the ratio of the Aid flow (current US$) of Dominican Republic in 2004 to that in 2007?
Offer a very short reply. 0.24. What is the ratio of the Aid flow (current US$) in El Salvador in 2004 to that in 2007?
Keep it short and to the point. 0.81. What is the ratio of the Aid flow (current US$) of Mozambique in 2004 to that in 2007?
Give a very brief answer. 0.71. What is the ratio of the Aid flow (current US$) of Pakistan in 2004 to that in 2007?
Your response must be concise. 0.28. What is the ratio of the Aid flow (current US$) of Dominican Republic in 2004 to that in 2008?
Give a very brief answer. 0.8. What is the ratio of the Aid flow (current US$) in El Salvador in 2004 to that in 2008?
Offer a terse response. 0.65. What is the ratio of the Aid flow (current US$) in Mozambique in 2004 to that in 2008?
Your answer should be very brief. 0.66. What is the ratio of the Aid flow (current US$) in Pakistan in 2004 to that in 2008?
Your answer should be very brief. 0.29. What is the ratio of the Aid flow (current US$) in Dominican Republic in 2007 to that in 2008?
Your answer should be compact. 3.35. What is the ratio of the Aid flow (current US$) in Mozambique in 2007 to that in 2008?
Make the answer very short. 0.93. What is the ratio of the Aid flow (current US$) in Pakistan in 2007 to that in 2008?
Your answer should be very brief. 1.01. What is the difference between the highest and the second highest Aid flow (current US$) of Dominican Republic?
Offer a very short reply. 4.70e+05. What is the difference between the highest and the second highest Aid flow (current US$) in El Salvador?
Offer a very short reply. 6.20e+05. What is the difference between the highest and the second highest Aid flow (current US$) in Mozambique?
Your response must be concise. 5.46e+06. What is the difference between the highest and the lowest Aid flow (current US$) in Dominican Republic?
Offer a very short reply. 6.50e+05. What is the difference between the highest and the lowest Aid flow (current US$) in El Salvador?
Keep it short and to the point. 2.81e+06. What is the difference between the highest and the lowest Aid flow (current US$) of Mozambique?
Offer a terse response. 6.77e+07. What is the difference between the highest and the lowest Aid flow (current US$) in Pakistan?
Keep it short and to the point. 2.66e+06. 